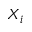Convert formula to latex. <formula><loc_0><loc_0><loc_500><loc_500>X _ { i }</formula> 